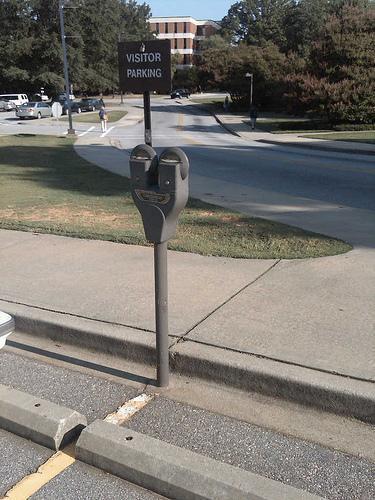How many signs do you see?
Give a very brief answer. 1. How many orange cats are there in the image?
Give a very brief answer. 0. 